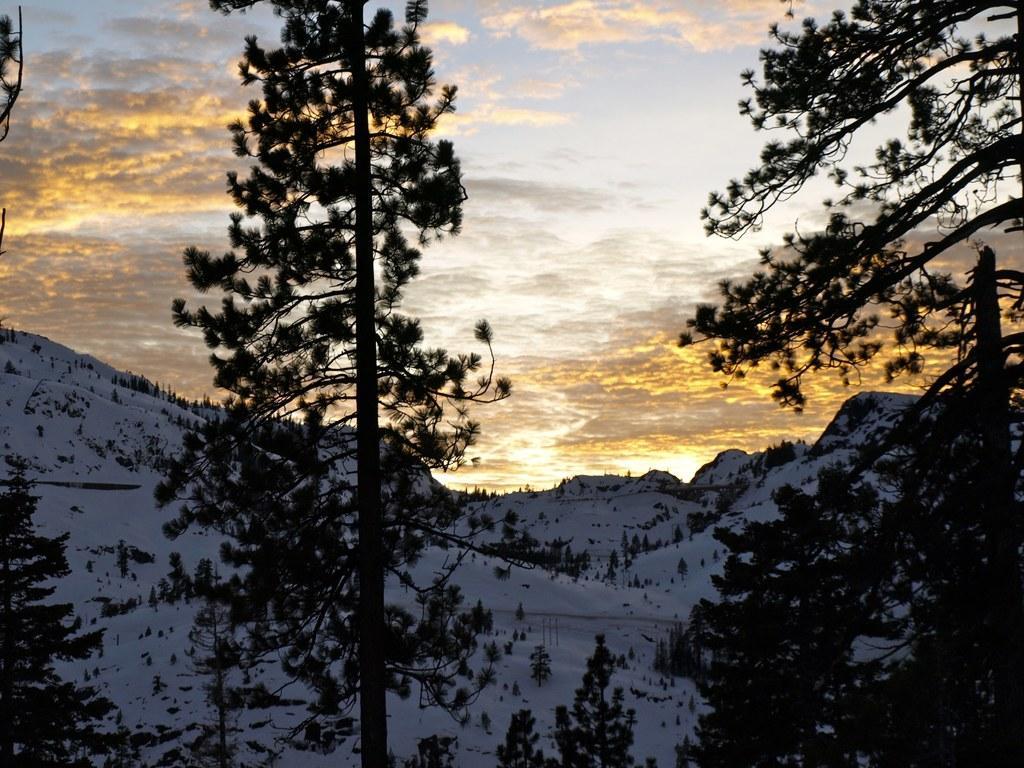Please provide a concise description of this image. In this image we can see sky with clouds, trees and hills. 